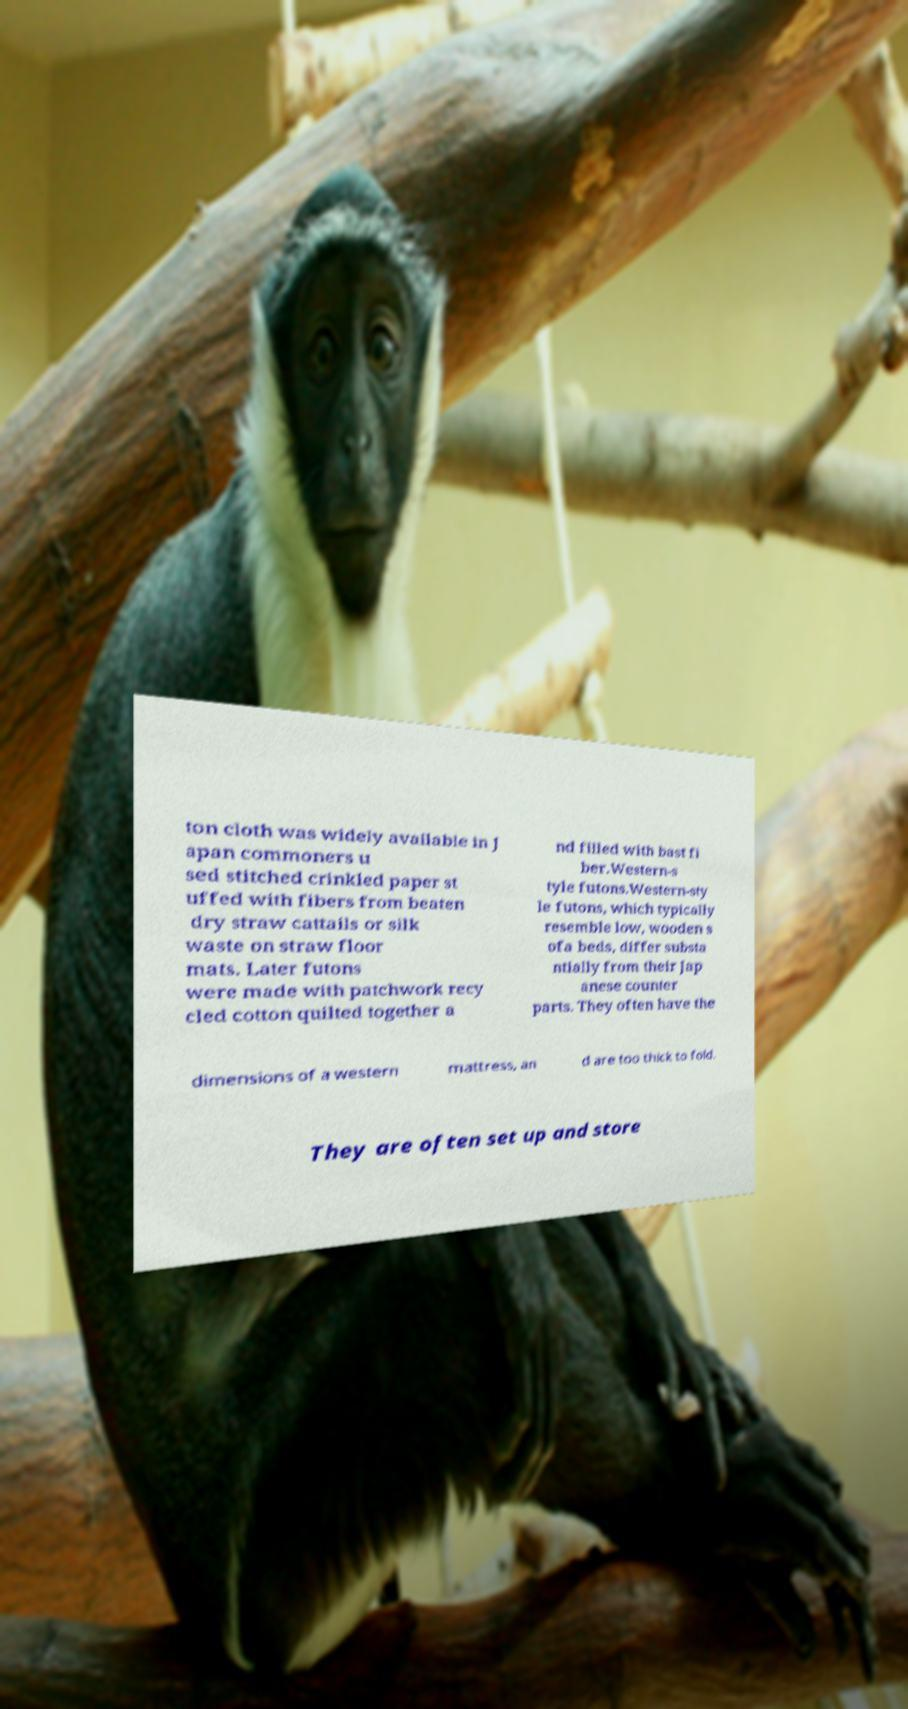Please read and relay the text visible in this image. What does it say? ton cloth was widely available in J apan commoners u sed stitched crinkled paper st uffed with fibers from beaten dry straw cattails or silk waste on straw floor mats. Later futons were made with patchwork recy cled cotton quilted together a nd filled with bast fi ber.Western-s tyle futons.Western-sty le futons, which typically resemble low, wooden s ofa beds, differ substa ntially from their Jap anese counter parts. They often have the dimensions of a western mattress, an d are too thick to fold. They are often set up and store 